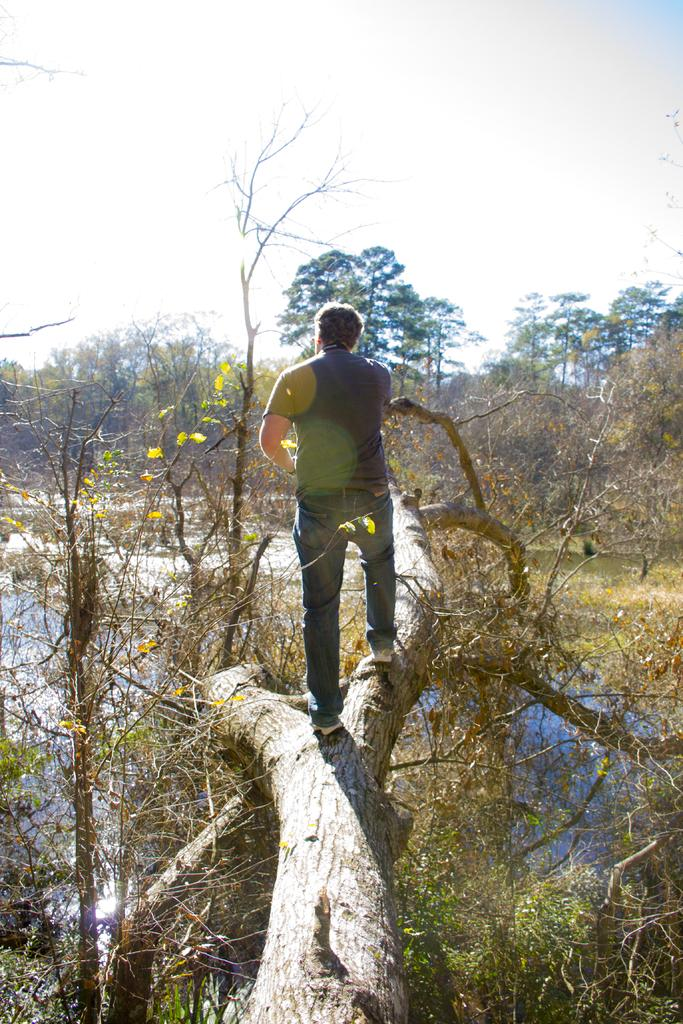What is the man in the image doing? The man is standing on a branch in the image. What can be seen in the image besides the man? There are plants and water visible in the image. What is visible in the background of the image? There are trees and the sky visible in the background of the image. What idea does the man have about paying off his debt in the image? There is no indication in the image about the man having any ideas or debts. 